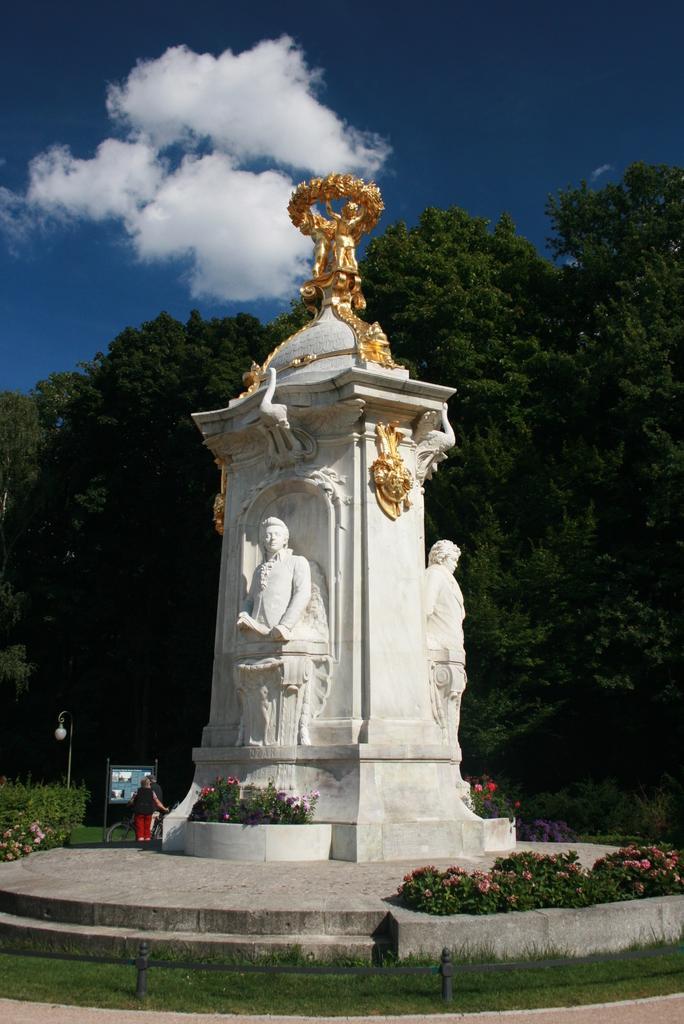Can you describe this image briefly? In this image we can see the statues, plants, grass, light pole, a board and also the trees. We can also see a person holding the bicycle. At the top we can see the sky with some clouds. 